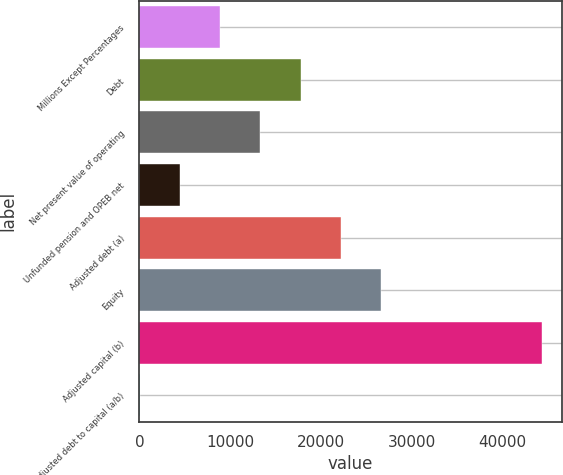<chart> <loc_0><loc_0><loc_500><loc_500><bar_chart><fcel>Millions Except Percentages<fcel>Debt<fcel>Net present value of operating<fcel>Unfunded pension and OPEB net<fcel>Adjusted debt (a)<fcel>Equity<fcel>Adjusted capital (b)<fcel>Adjusted debt to capital (a/b)<nl><fcel>8902.32<fcel>17760.7<fcel>13331.5<fcel>4473.11<fcel>22190<fcel>26619.2<fcel>44336<fcel>43.9<nl></chart> 